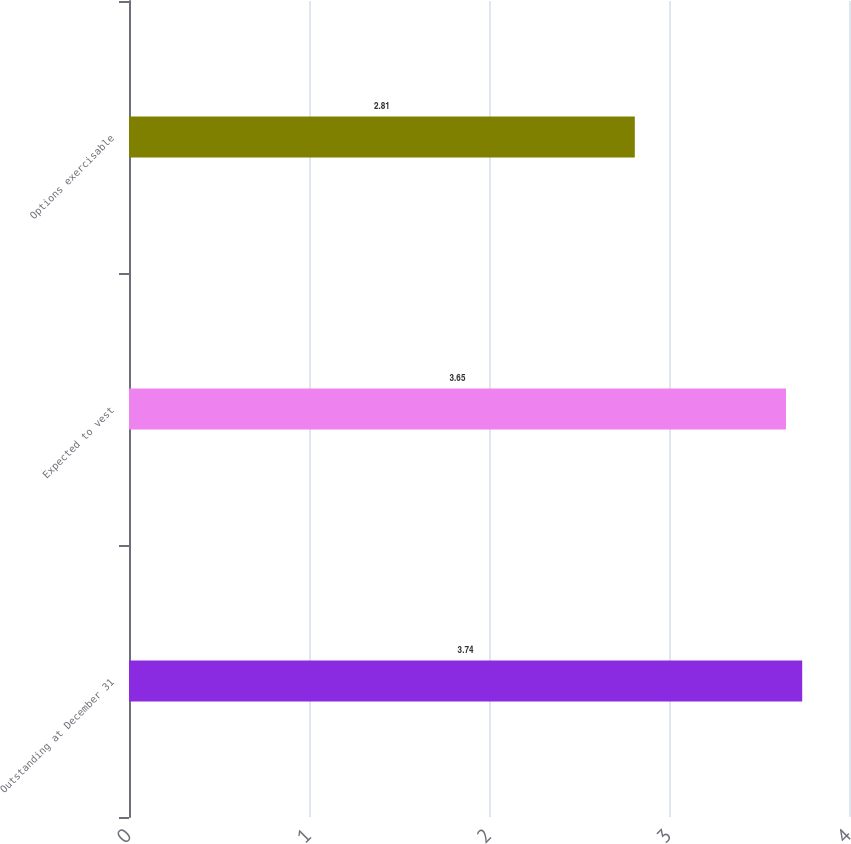Convert chart to OTSL. <chart><loc_0><loc_0><loc_500><loc_500><bar_chart><fcel>Outstanding at December 31<fcel>Expected to vest<fcel>Options exercisable<nl><fcel>3.74<fcel>3.65<fcel>2.81<nl></chart> 